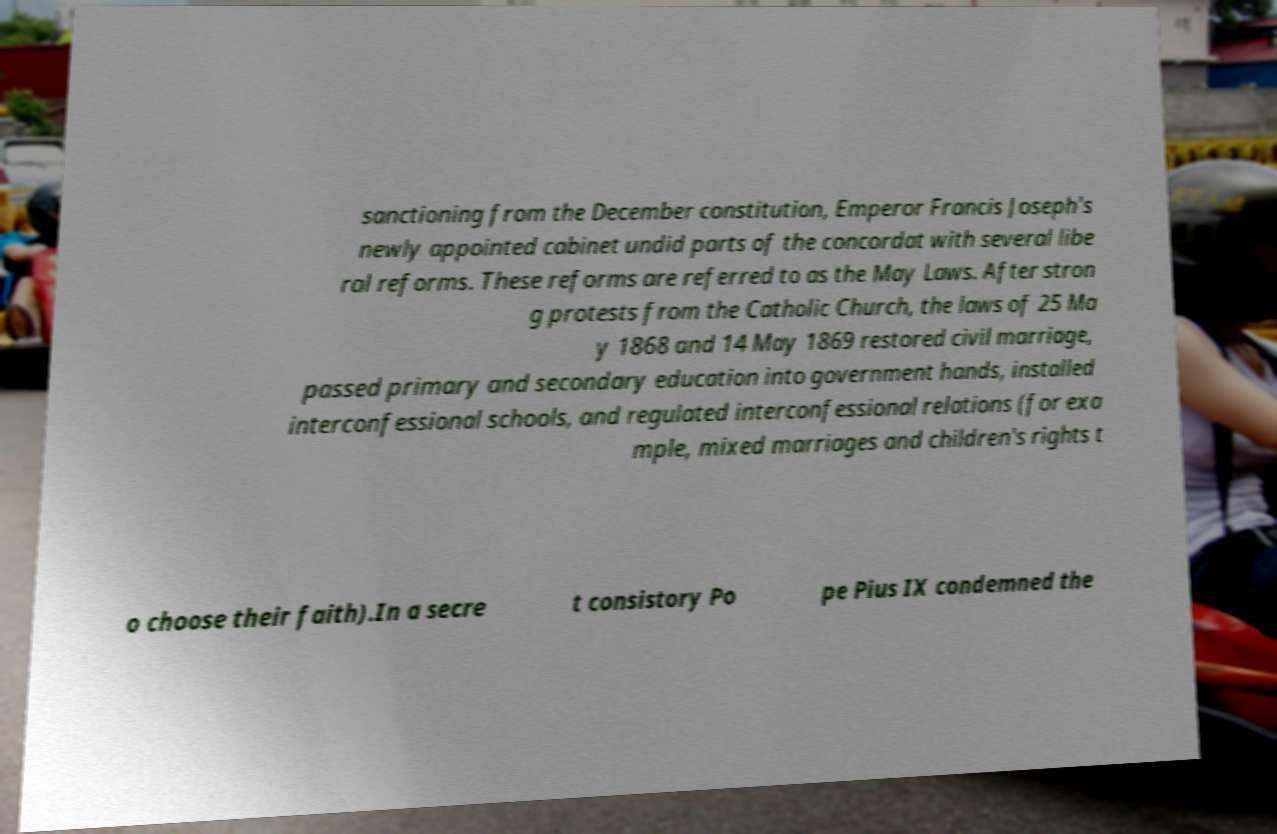Please read and relay the text visible in this image. What does it say? sanctioning from the December constitution, Emperor Francis Joseph's newly appointed cabinet undid parts of the concordat with several libe ral reforms. These reforms are referred to as the May Laws. After stron g protests from the Catholic Church, the laws of 25 Ma y 1868 and 14 May 1869 restored civil marriage, passed primary and secondary education into government hands, installed interconfessional schools, and regulated interconfessional relations (for exa mple, mixed marriages and children's rights t o choose their faith).In a secre t consistory Po pe Pius IX condemned the 